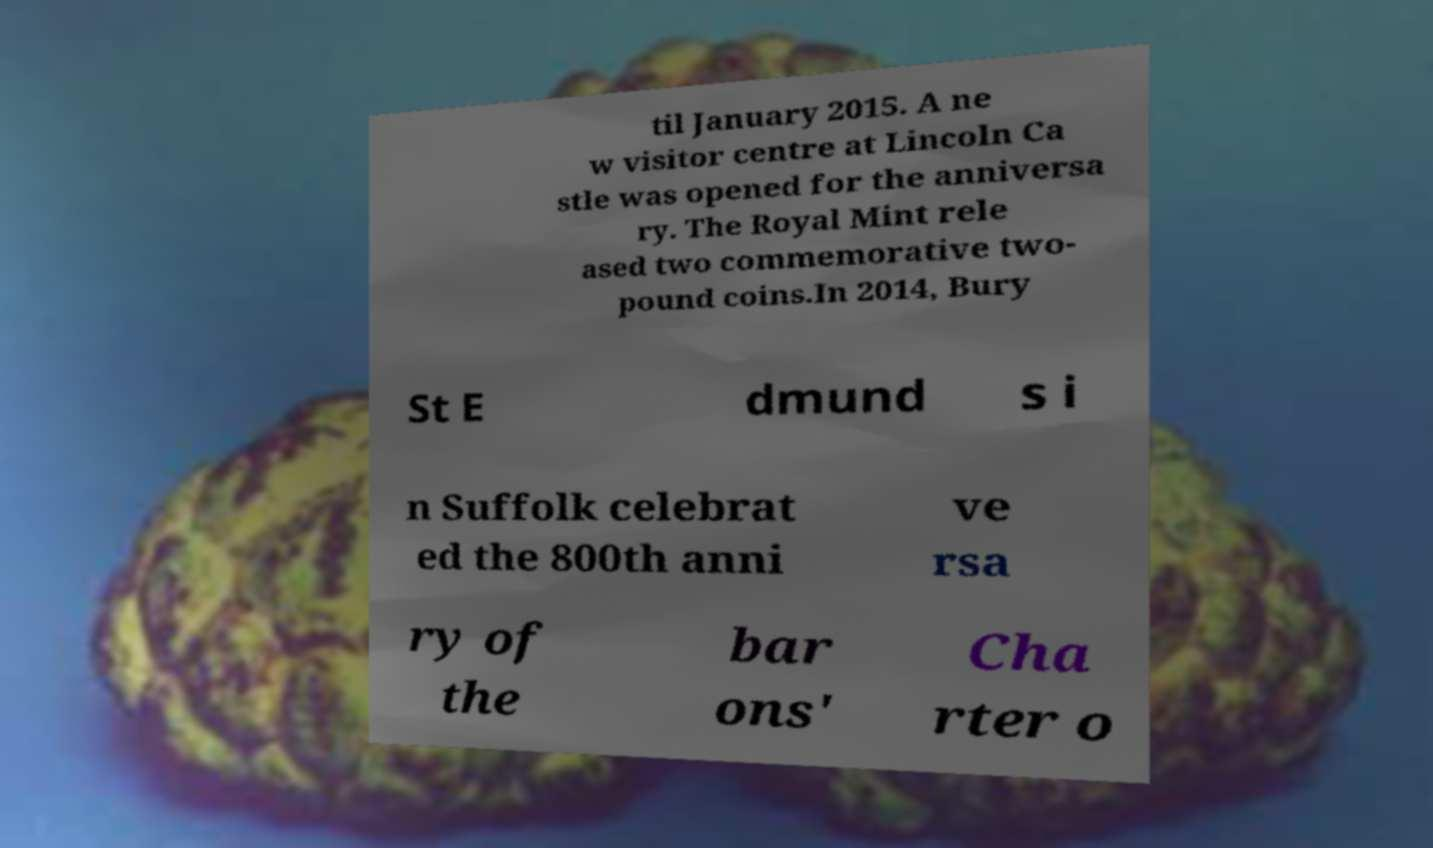Could you assist in decoding the text presented in this image and type it out clearly? til January 2015. A ne w visitor centre at Lincoln Ca stle was opened for the anniversa ry. The Royal Mint rele ased two commemorative two- pound coins.In 2014, Bury St E dmund s i n Suffolk celebrat ed the 800th anni ve rsa ry of the bar ons' Cha rter o 